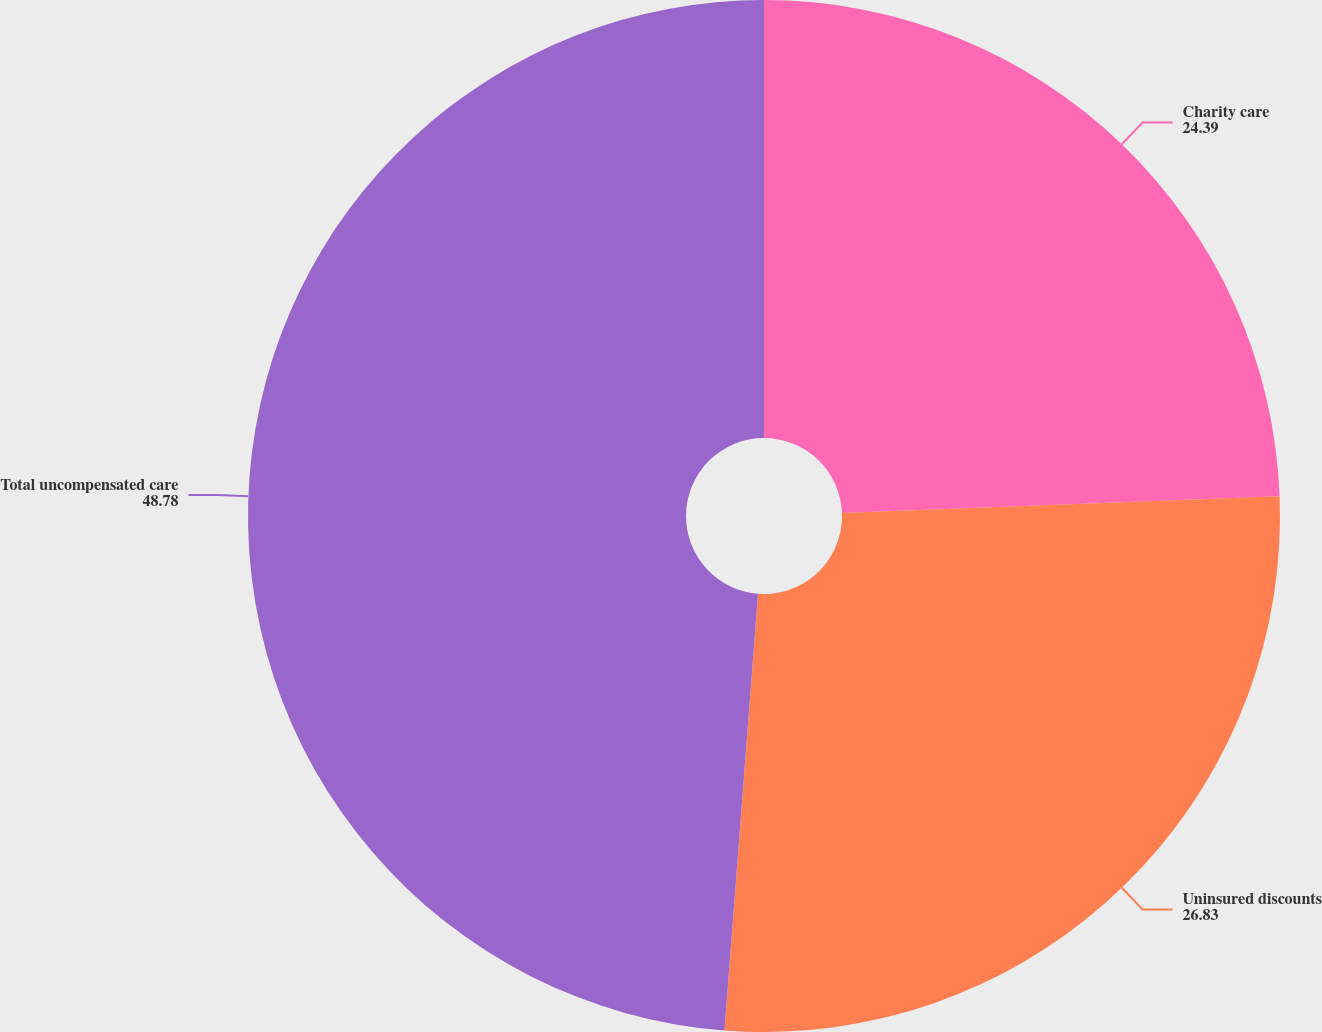Convert chart to OTSL. <chart><loc_0><loc_0><loc_500><loc_500><pie_chart><fcel>Charity care<fcel>Uninsured discounts<fcel>Total uncompensated care<nl><fcel>24.39%<fcel>26.83%<fcel>48.78%<nl></chart> 